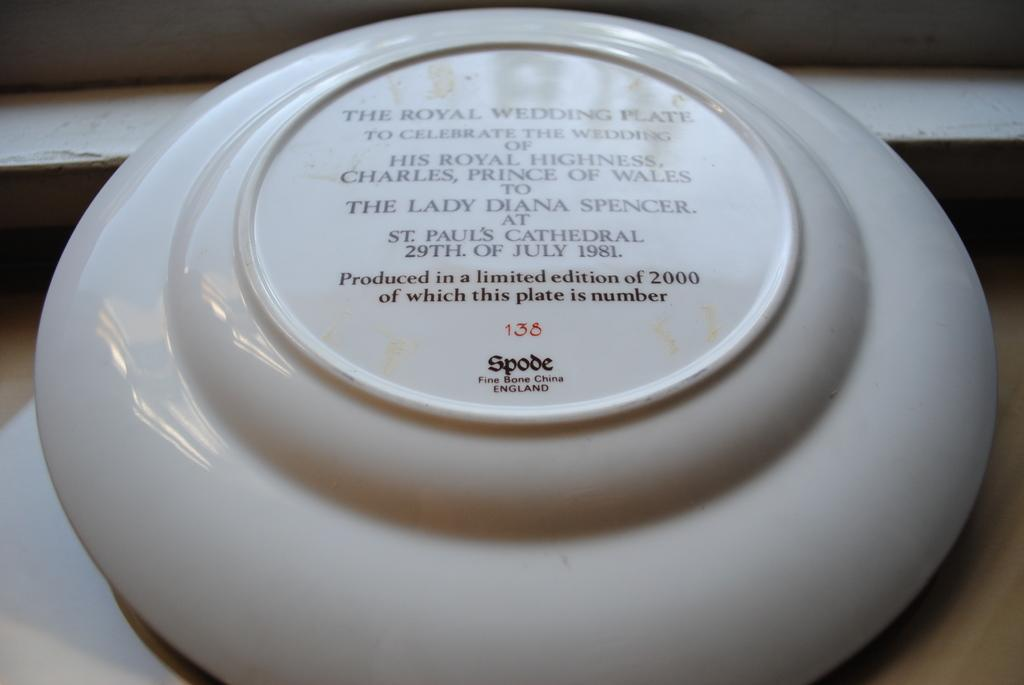What object is present in the image that might be used for serving food? There is a plate in the image. What additional feature can be seen on the plate? There is text on the plate. What type of books is the plate holding in the image? There are no books present in the image; it only features a plate with text. 